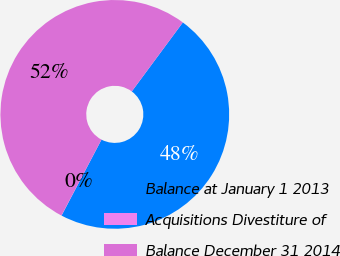Convert chart. <chart><loc_0><loc_0><loc_500><loc_500><pie_chart><fcel>Balance at January 1 2013<fcel>Acquisitions Divestiture of<fcel>Balance December 31 2014<nl><fcel>47.57%<fcel>0.02%<fcel>52.41%<nl></chart> 